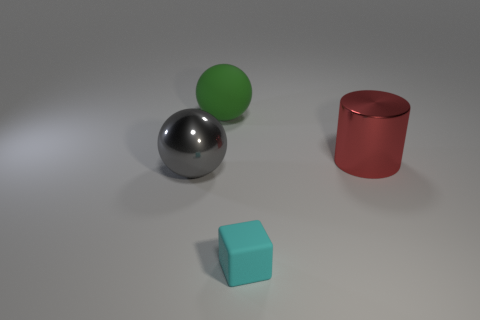Does the sphere that is in front of the red shiny object have the same size as the matte thing in front of the large red shiny cylinder?
Keep it short and to the point. No. There is a rubber cube; are there any rubber things behind it?
Give a very brief answer. Yes. The big sphere in front of the shiny thing right of the big gray metallic thing is what color?
Your answer should be compact. Gray. Are there fewer red shiny blocks than large metal balls?
Offer a terse response. Yes. How many other large red objects have the same shape as the red thing?
Ensure brevity in your answer.  0. There is a cylinder that is the same size as the gray object; what color is it?
Keep it short and to the point. Red. Are there the same number of red metallic cylinders in front of the metal cylinder and cyan matte blocks that are in front of the cyan matte object?
Offer a very short reply. Yes. Are there any gray shiny things that have the same size as the cylinder?
Provide a succinct answer. Yes. The cylinder is what size?
Offer a terse response. Large. Is the number of gray things that are behind the metallic sphere the same as the number of red matte cubes?
Make the answer very short. Yes. 